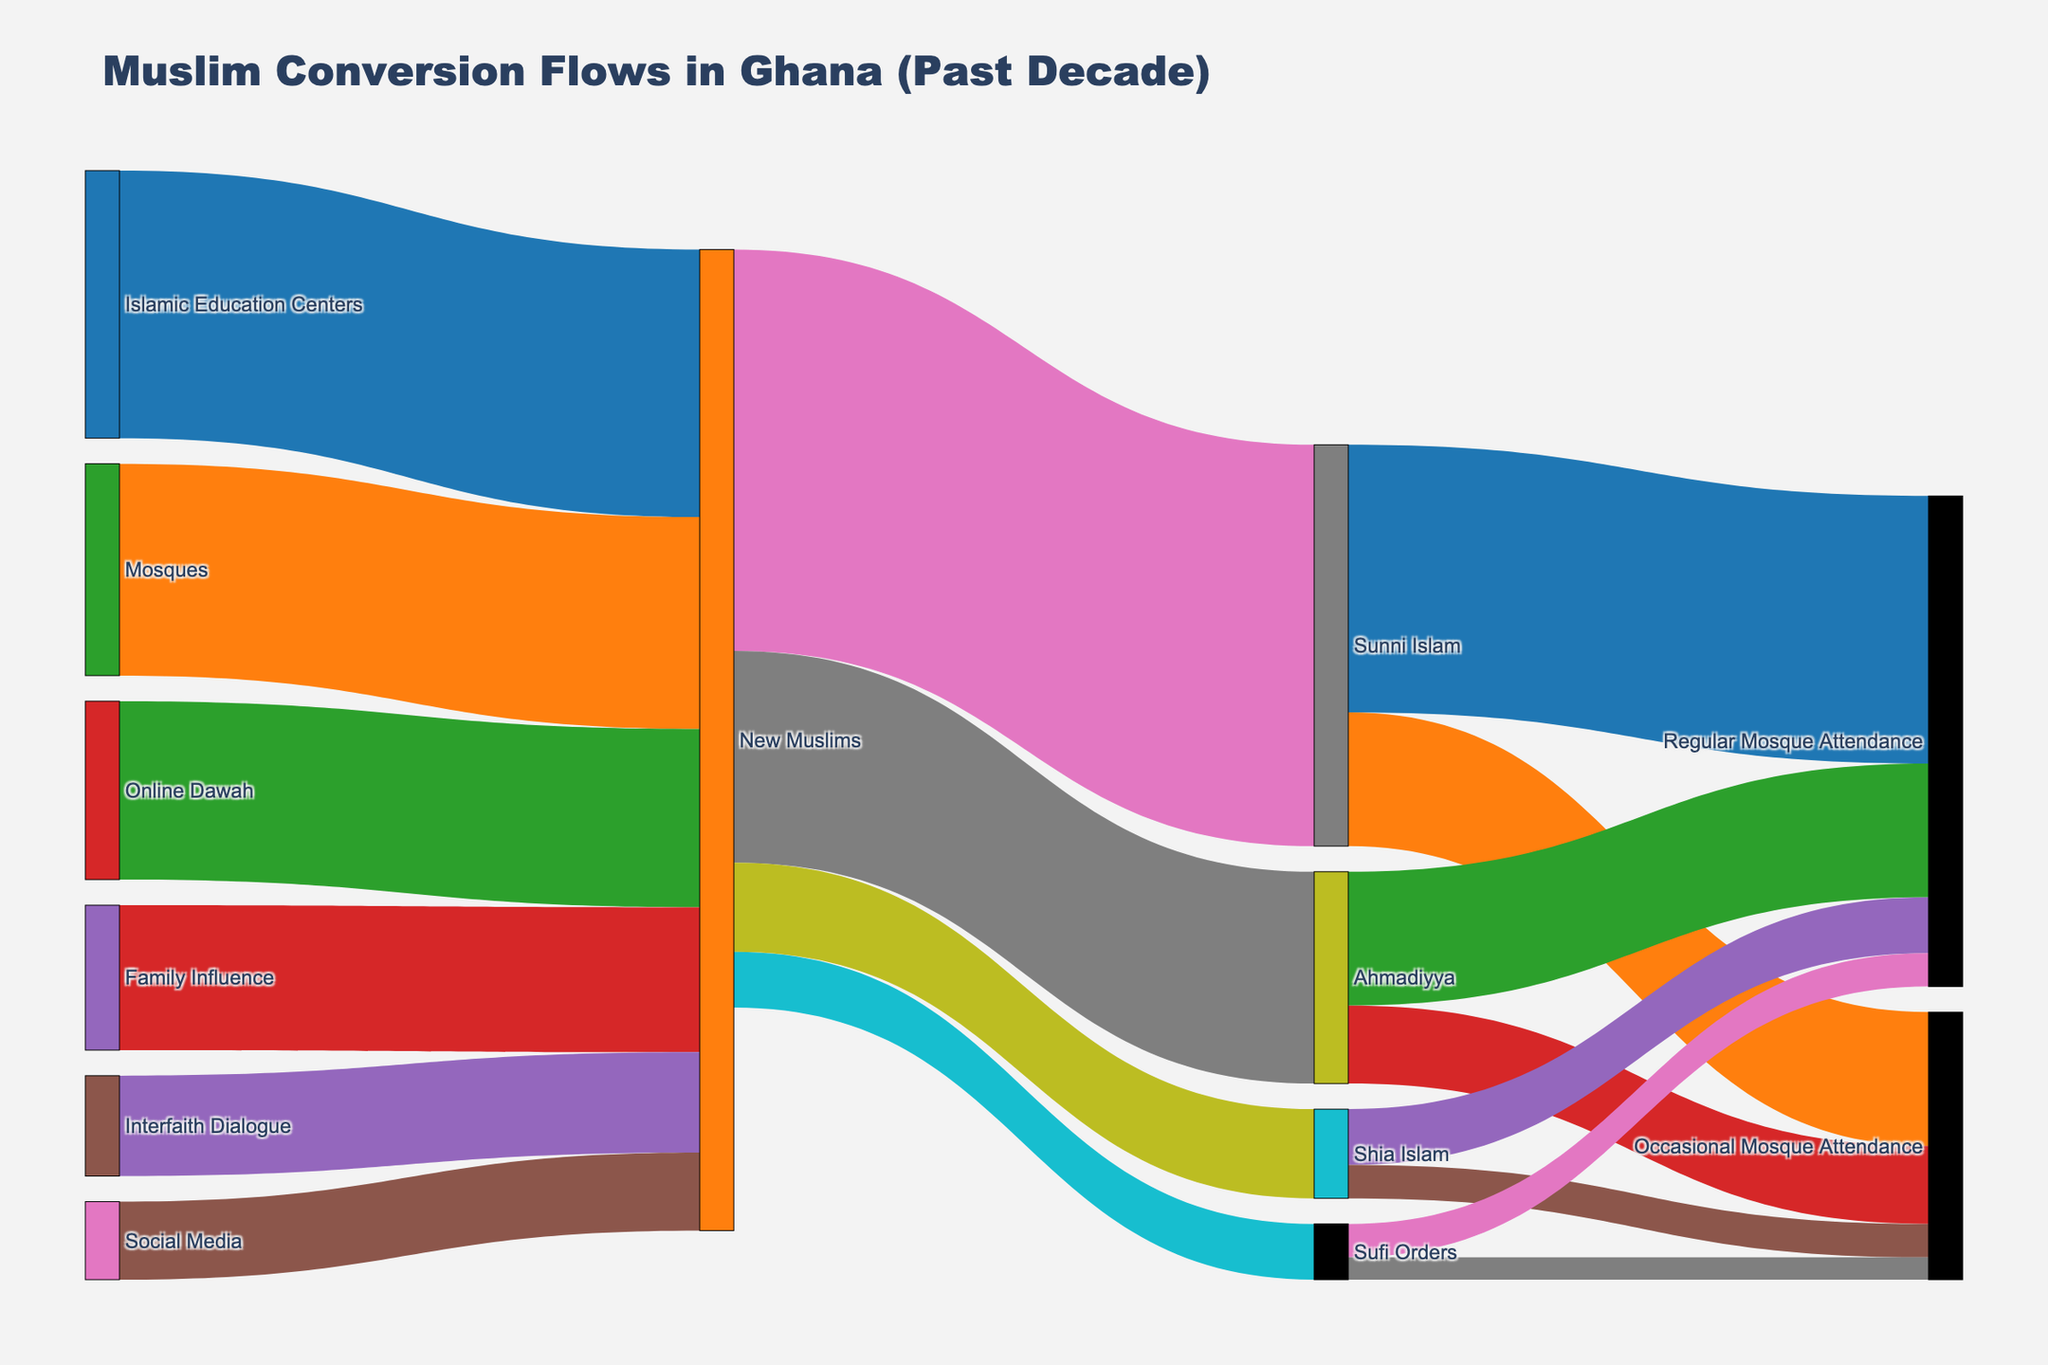What is the title of the Sankey diagram? The diagram's title is displayed at the top center of the figure. It provides an overall summary of the plot's content.
Answer: Muslim Conversion Flows in Ghana (Past Decade) How many total converts to Islam were from Islamic Education Centers? Look at the link from "Islamic Education Centers" to "New Muslims" and observe the value associated with this link.
Answer: 1200 Which are the sources of conversion to Sunni Islam? Identify all the paths that lead eventually to "Sunni Islam". Look for arrows pointing towards "Sunni Islam".
Answer: New Muslims Which conversion source has the lowest number of converts? Compare the values associated with each source link leading to "New Muslims" to find the smallest value.
Answer: Social Media How many total converts attend mosques regularly in total? Sum the values of all the links leading to "Regular Mosque Attendance" for each destination (Sunni Islam, Ahmadiyya, Shia Islam, Sufi Orders).
Answer: 2200 (1200 + 600 + 250 + 150) Compare the number of converts to Ahmadiyya and Shia Islam. Which one has more? Identify the values leading to "Ahmadiyya" and "Shia Islam" from "New Muslims", and compare these values.
Answer: Ahmadiyya What is the total number of converts influenced by Family Influence and Mosques? Add together the values from "Family Influence" and "Mosques" to "New Muslims".
Answer: 1600 (650+950) What percentage of Sunni Islam converts attend mosques occasionally? Calculate the percentage by dividing the number who attend occasionally by the total Sunni Islam converts, then multiply by 100.
Answer: 33.33% (600 out of 1800) Which destination has the highest number of regular mosque attendees? Compare the values for "Regular Mosque Attendance" linked to each religious group and identify the highest one.
Answer: Sunni Islam What is the difference in the number of irregular mosque attendees between Ahmadiyya and Sufi Orders? Subtract the number of "Occasional Mosque Attendance" linked to Sufi Orders from those linked to Ahmadiyya.
Answer: 250 (350 - 100) 